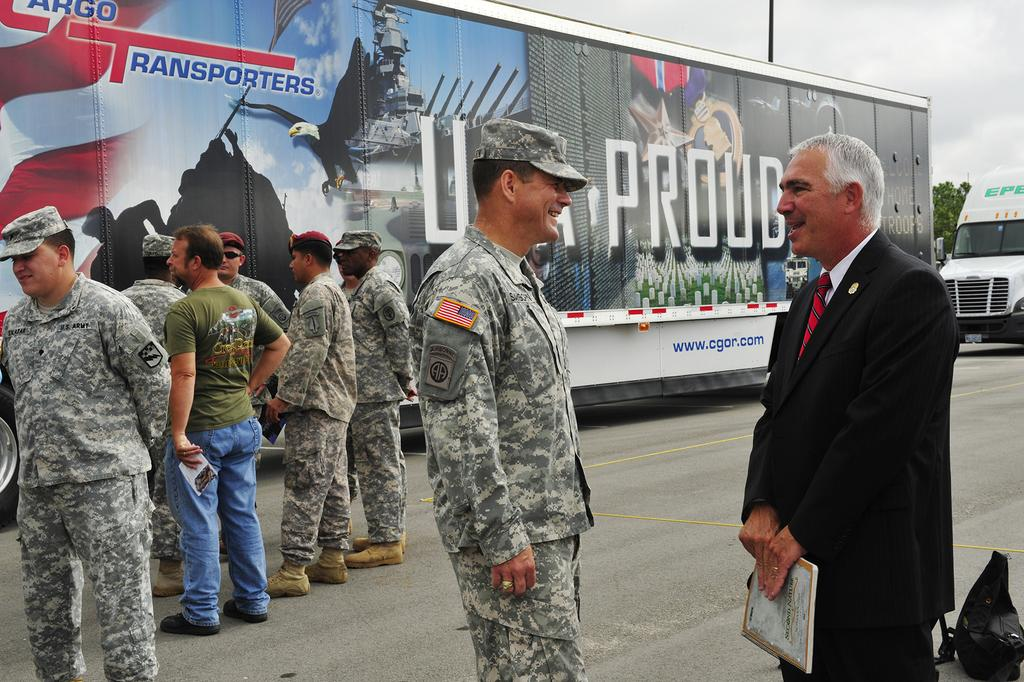What can be seen in the image involving people? There are people standing in the image. What else is present on the road in the image? There are vehicles on the road in the image. What object is on the road that is not a vehicle? There is a bag on the road in the image. What can be seen in the background of the image that is not related to the road or sky? There are leaves and a pole visible in the background of the image. What is visible in the background of the image that takes up a large portion of the sky? The sky is visible in the background of the image. Can you tell me where the locket is hidden in the image? There is no locket present in the image. What type of joke can be seen being told by the people in the image? There is no joke being told by the people in the image. 